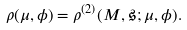Convert formula to latex. <formula><loc_0><loc_0><loc_500><loc_500>\rho ( \mu , \phi ) = \rho ^ { ( 2 ) } ( M , \mathfrak { s } ; \mu , \phi ) .</formula> 